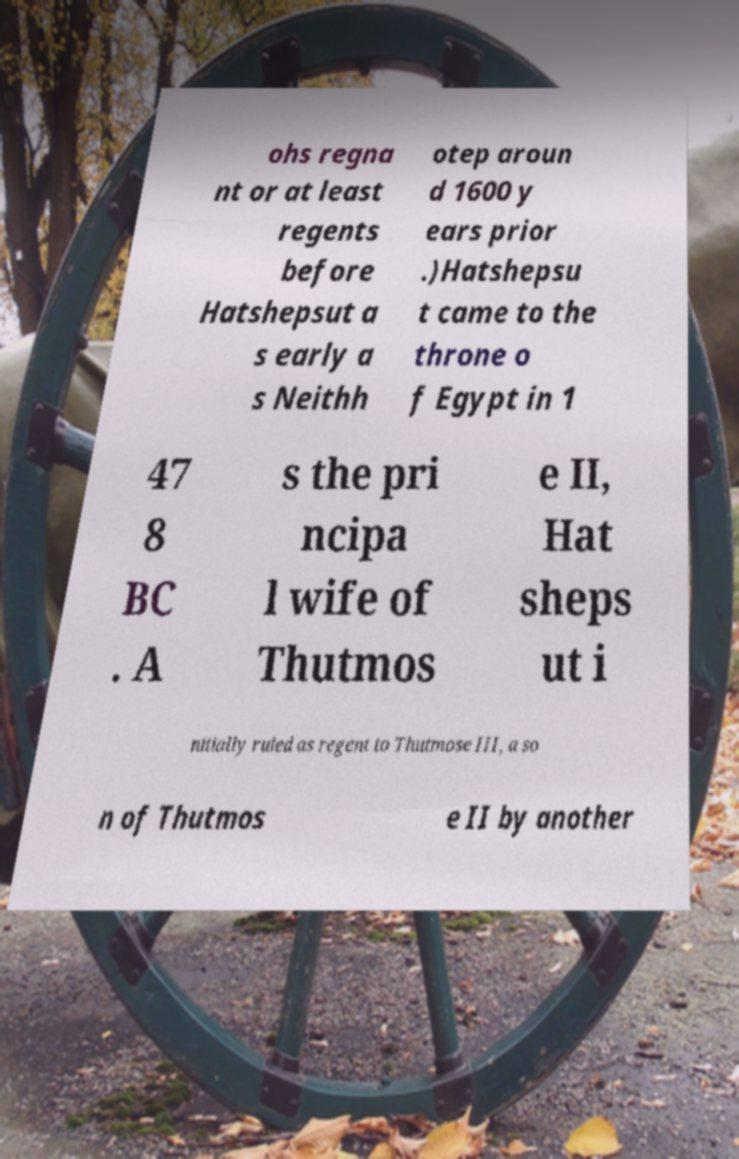For documentation purposes, I need the text within this image transcribed. Could you provide that? ohs regna nt or at least regents before Hatshepsut a s early a s Neithh otep aroun d 1600 y ears prior .)Hatshepsu t came to the throne o f Egypt in 1 47 8 BC . A s the pri ncipa l wife of Thutmos e II, Hat sheps ut i nitially ruled as regent to Thutmose III, a so n of Thutmos e II by another 